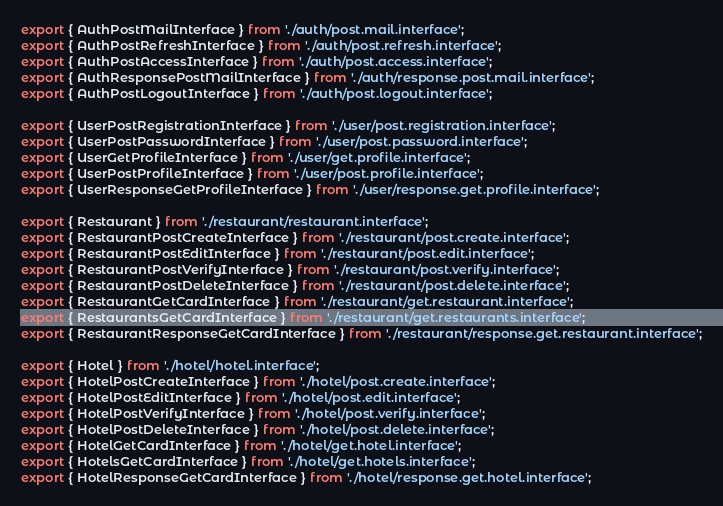<code> <loc_0><loc_0><loc_500><loc_500><_TypeScript_>
export { AuthPostMailInterface } from './auth/post.mail.interface';
export { AuthPostRefreshInterface } from './auth/post.refresh.interface';
export { AuthPostAccessInterface } from './auth/post.access.interface';
export { AuthResponsePostMailInterface } from './auth/response.post.mail.interface';
export { AuthPostLogoutInterface } from './auth/post.logout.interface';

export { UserPostRegistrationInterface } from './user/post.registration.interface';
export { UserPostPasswordInterface } from './user/post.password.interface';
export { UserGetProfileInterface } from './user/get.profile.interface';
export { UserPostProfileInterface } from './user/post.profile.interface';
export { UserResponseGetProfileInterface } from './user/response.get.profile.interface';

export { Restaurant } from './restaurant/restaurant.interface';
export { RestaurantPostCreateInterface } from './restaurant/post.create.interface';
export { RestaurantPostEditInterface } from './restaurant/post.edit.interface';
export { RestaurantPostVerifyInterface } from './restaurant/post.verify.interface';
export { RestaurantPostDeleteInterface } from './restaurant/post.delete.interface';
export { RestaurantGetCardInterface } from './restaurant/get.restaurant.interface';
export { RestaurantsGetCardInterface } from './restaurant/get.restaurants.interface';
export { RestaurantResponseGetCardInterface } from './restaurant/response.get.restaurant.interface';

export { Hotel } from './hotel/hotel.interface';
export { HotelPostCreateInterface } from './hotel/post.create.interface';
export { HotelPostEditInterface } from './hotel/post.edit.interface';
export { HotelPostVerifyInterface } from './hotel/post.verify.interface';
export { HotelPostDeleteInterface } from './hotel/post.delete.interface';
export { HotelGetCardInterface } from './hotel/get.hotel.interface';
export { HotelsGetCardInterface } from './hotel/get.hotels.interface';
export { HotelResponseGetCardInterface } from './hotel/response.get.hotel.interface';
</code> 